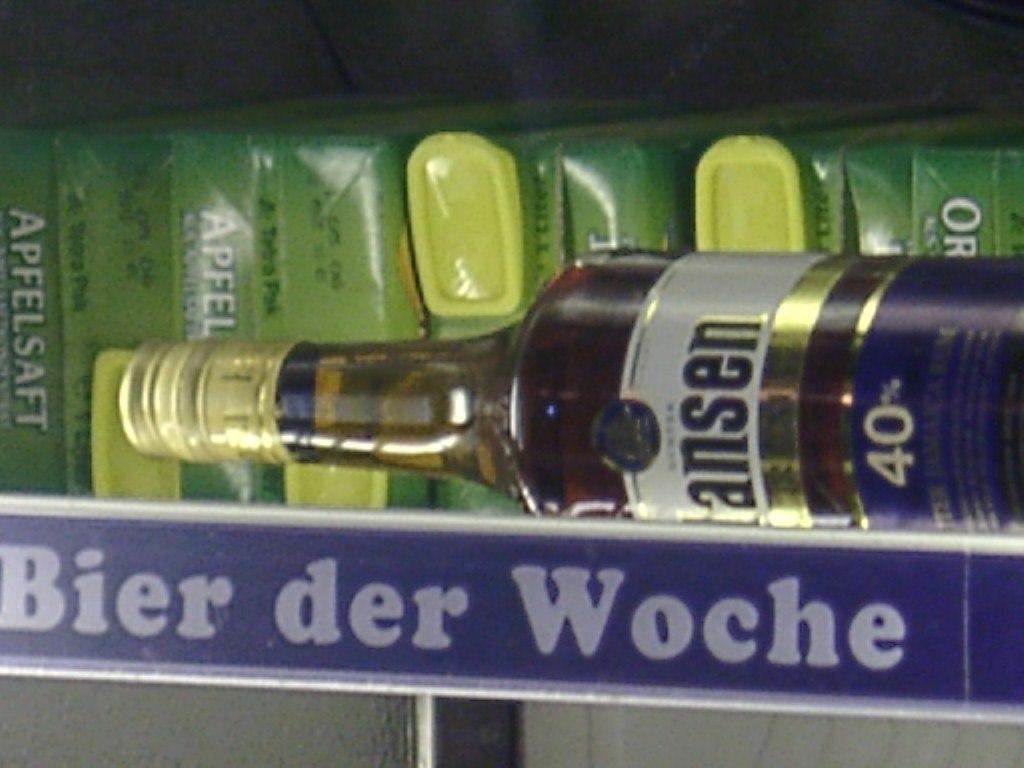What object can be seen in the image that might contain a liquid? There is a bottle in the image that might contain a liquid. What flat, rectangular object is present in the image? There is a board in the image. What type of container is visible in the image? There are boxes in the image. How many pairs of shoes are visible in the image? There are no shoes present in the image. What type of vehicle is parked in the background of the image? There is no vehicle present in the image. 